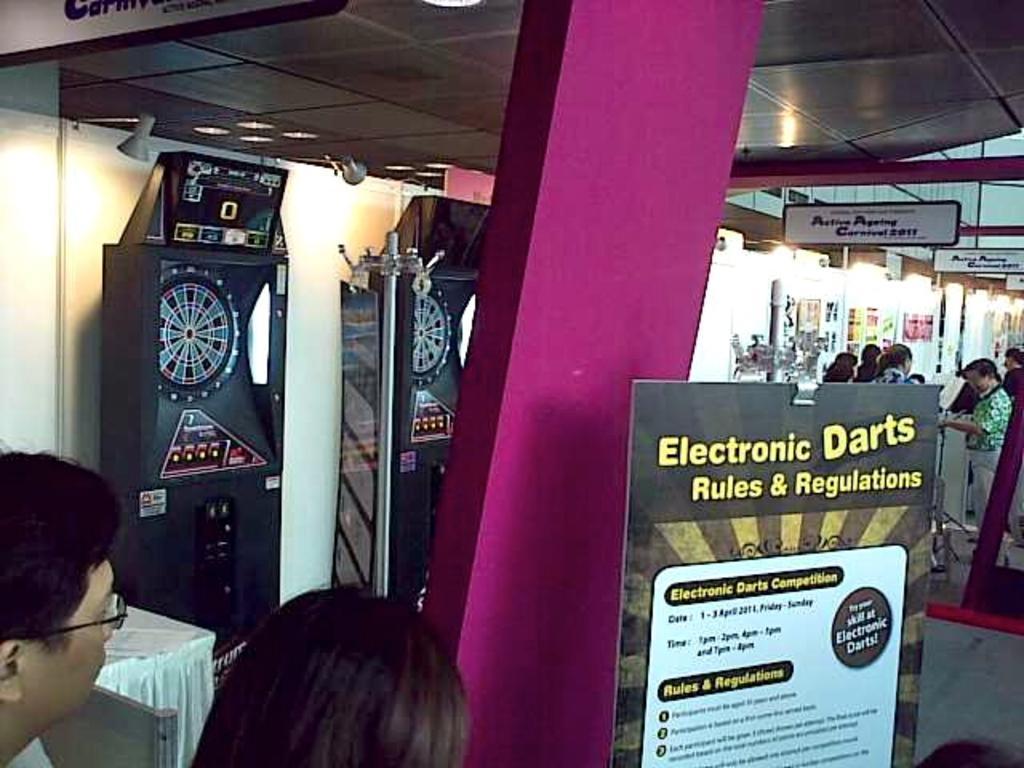In one or two sentences, can you explain what this image depicts? In this image we can see a few people standing, on the left we can see electronic machines, we can see the table, on the right we can see some written text on the boards, pillar, we can see the ceiling with lights. 